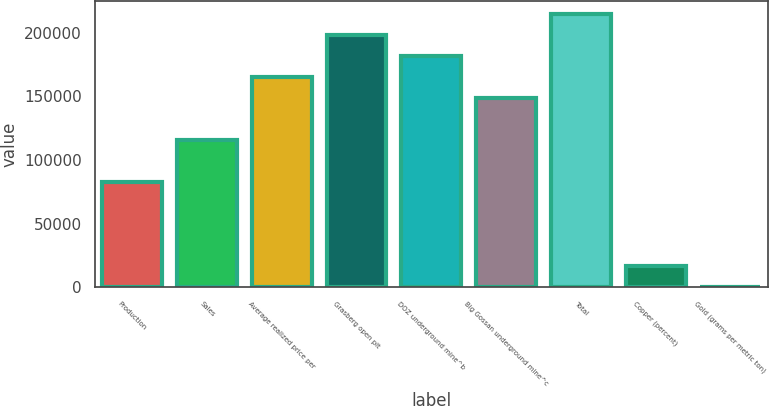<chart> <loc_0><loc_0><loc_500><loc_500><bar_chart><fcel>Production<fcel>Sales<fcel>Average realized price per<fcel>Grasberg open pit<fcel>DOZ underground mine^b<fcel>Big Gossan underground mine^c<fcel>Total<fcel>Copper (percent)<fcel>Gold (grams per metric ton)<nl><fcel>82500.3<fcel>115500<fcel>165000<fcel>198000<fcel>181500<fcel>148500<fcel>214500<fcel>16500.5<fcel>0.59<nl></chart> 